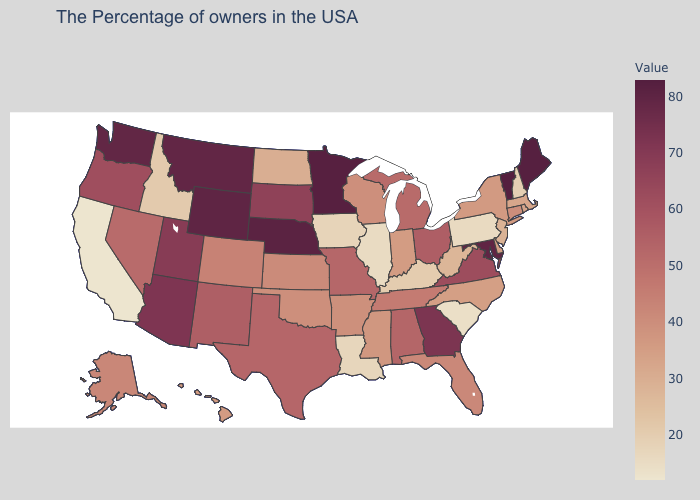Which states have the highest value in the USA?
Write a very short answer. Vermont. Which states have the highest value in the USA?
Keep it brief. Vermont. Among the states that border Nebraska , does Wyoming have the highest value?
Short answer required. Yes. 